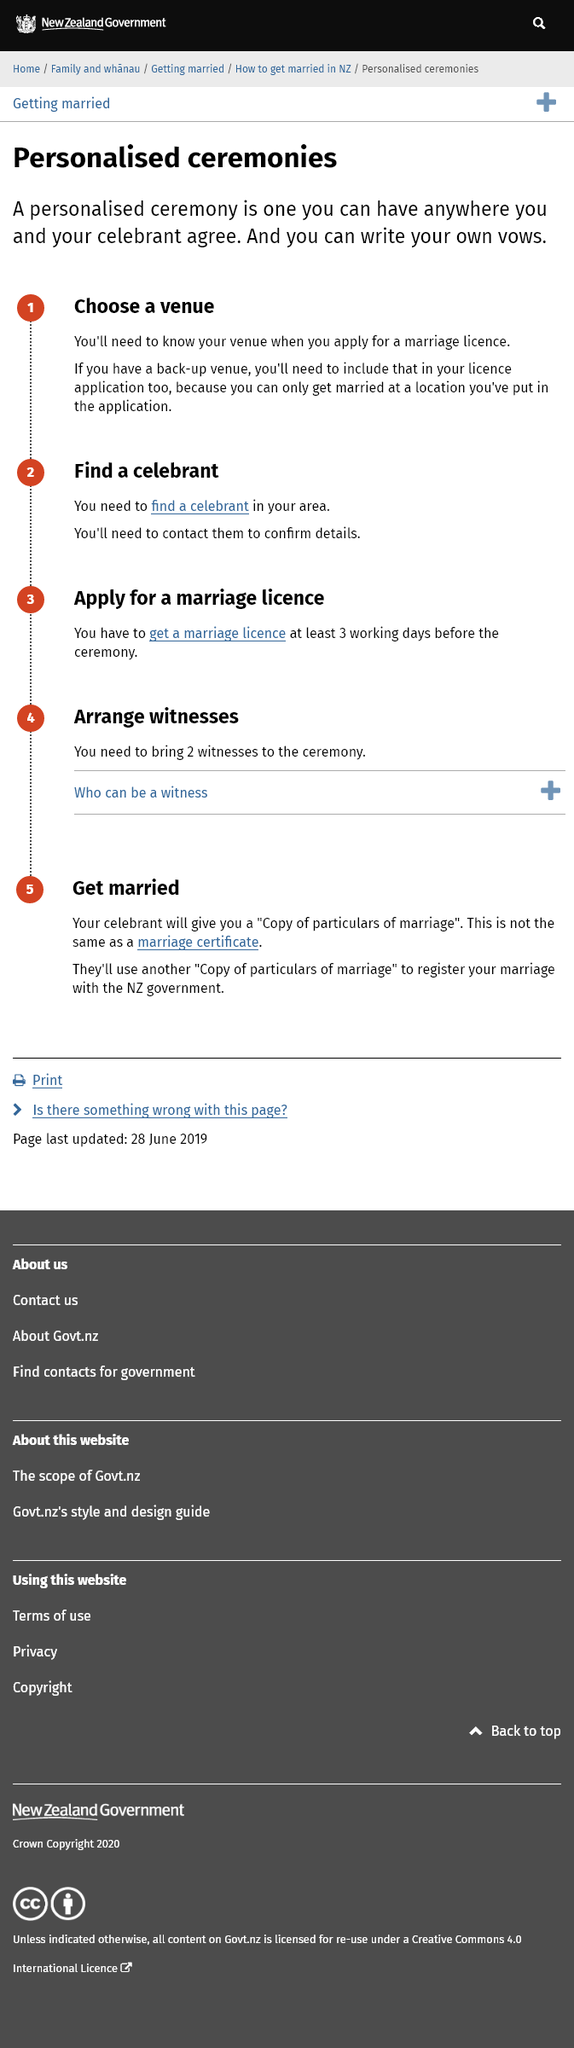Mention a couple of crucial points in this snapshot. The first step in a personalized ceremony is to choose a venue for the event. The New Zealand government is informed of the marriage through the filing of a copy of particulars. After finding a celebrant in your area, it is imperative that you contact them and confirm the details of their availability and services to ensure a smooth and successful ceremony. 